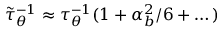Convert formula to latex. <formula><loc_0><loc_0><loc_500><loc_500>\tilde { \tau } _ { \theta } ^ { - 1 } \approx \tau _ { \theta } ^ { - 1 } ( 1 + \alpha _ { b } ^ { 2 } / 6 + \dots )</formula> 